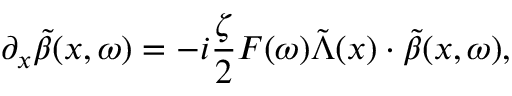<formula> <loc_0><loc_0><loc_500><loc_500>\partial _ { x } \tilde { \beta } ( x , \omega ) = - i \frac { \zeta } { 2 } F ( \omega ) \tilde { \Lambda } ( x ) \cdot \tilde { \beta } ( x , \omega ) ,</formula> 